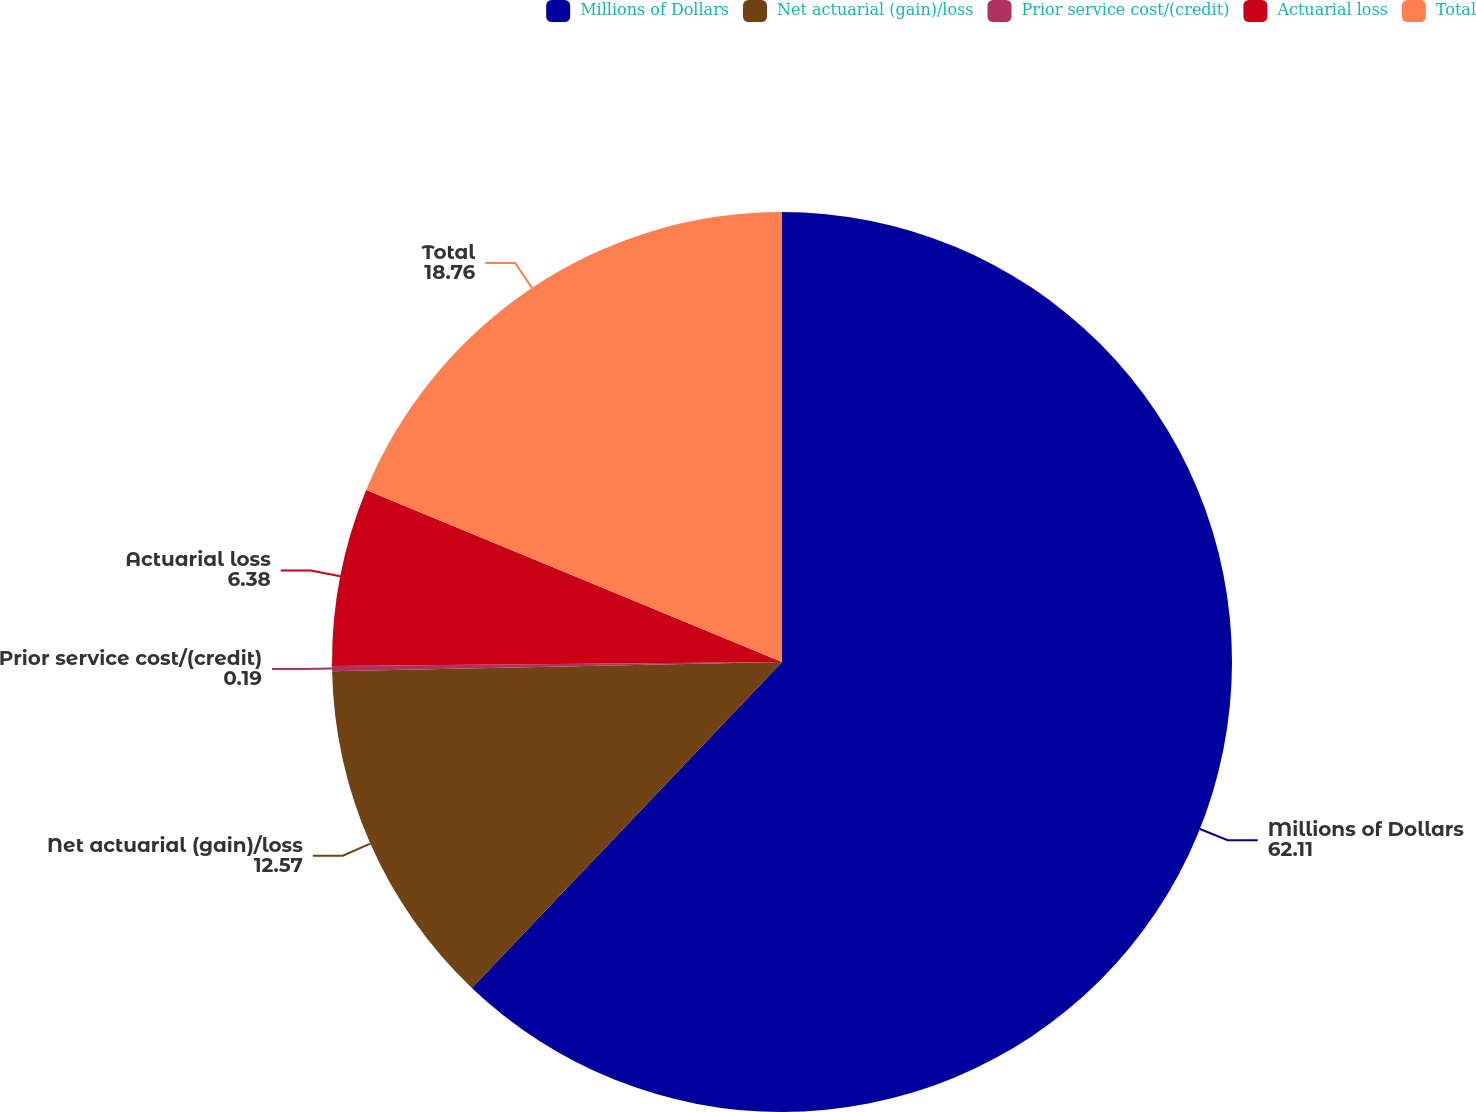Convert chart to OTSL. <chart><loc_0><loc_0><loc_500><loc_500><pie_chart><fcel>Millions of Dollars<fcel>Net actuarial (gain)/loss<fcel>Prior service cost/(credit)<fcel>Actuarial loss<fcel>Total<nl><fcel>62.11%<fcel>12.57%<fcel>0.19%<fcel>6.38%<fcel>18.76%<nl></chart> 